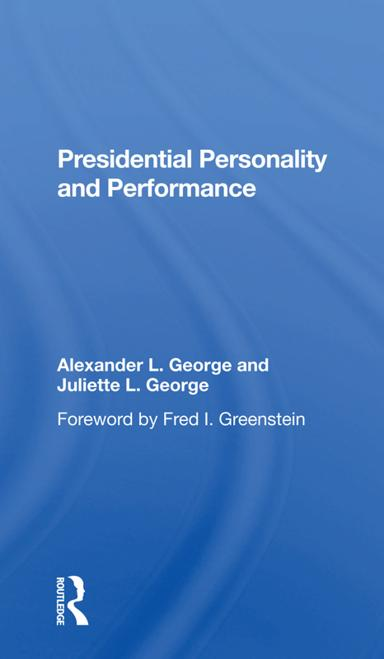Who wrote the foreword for the book? The foreword of the book 'Presidential Personality and Performance' was penned by Fred I. Greenstein, a distinguished scholar known for his expertise in American politics and presidential studies. 